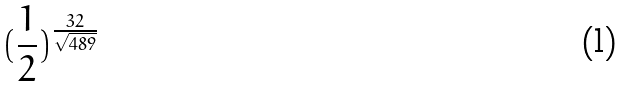<formula> <loc_0><loc_0><loc_500><loc_500>( \frac { 1 } { 2 } ) ^ { \frac { 3 2 } { \sqrt { 4 8 9 } } }</formula> 